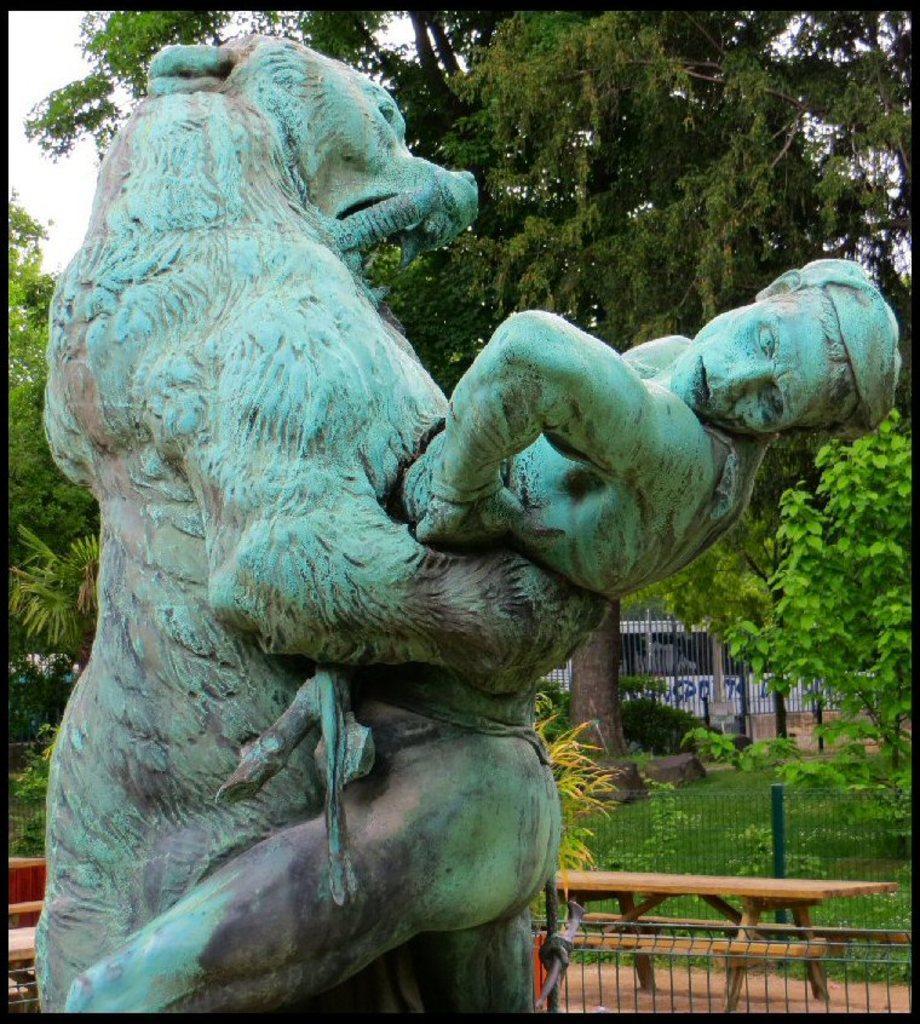Can you describe this image briefly? In this picture we can observe a statue of an animal and a human. There is a brown bench and a table on the ground. In the background there are trees and a sky. 